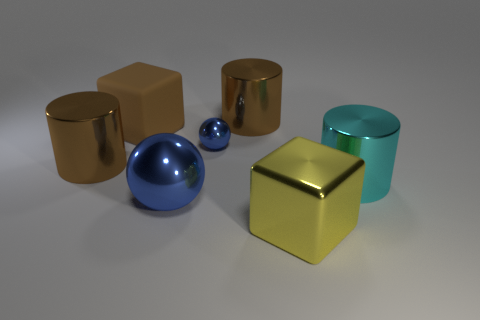The shiny cube is what color?
Your response must be concise. Yellow. What number of blue things are on the right side of the brown matte object behind the large blue sphere?
Make the answer very short. 2. Is there a block that is right of the brown metal cylinder that is to the right of the large blue ball?
Keep it short and to the point. Yes. Are there any brown rubber things to the right of the big blue metallic object?
Your answer should be very brief. No. Do the brown metal object in front of the small shiny object and the large blue metallic object have the same shape?
Your response must be concise. No. What number of large blue metal objects are the same shape as the small metal object?
Your answer should be very brief. 1. Is there a small red cylinder made of the same material as the large sphere?
Ensure brevity in your answer.  No. What material is the block that is behind the big metal cylinder on the left side of the brown cube?
Your answer should be very brief. Rubber. How big is the sphere that is in front of the cyan object?
Make the answer very short. Large. There is a rubber cube; does it have the same color as the large shiny cylinder on the left side of the large blue metal sphere?
Your answer should be very brief. Yes. 